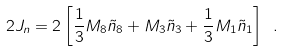<formula> <loc_0><loc_0><loc_500><loc_500>2 J _ { n } = 2 \left [ { \frac { 1 } { 3 } } M _ { 8 } { \tilde { n } } _ { 8 } + M _ { 3 } { \tilde { n } } _ { 3 } + { \frac { 1 } { 3 } } M _ { 1 } { \tilde { n } } _ { 1 } \right ] \ .</formula> 